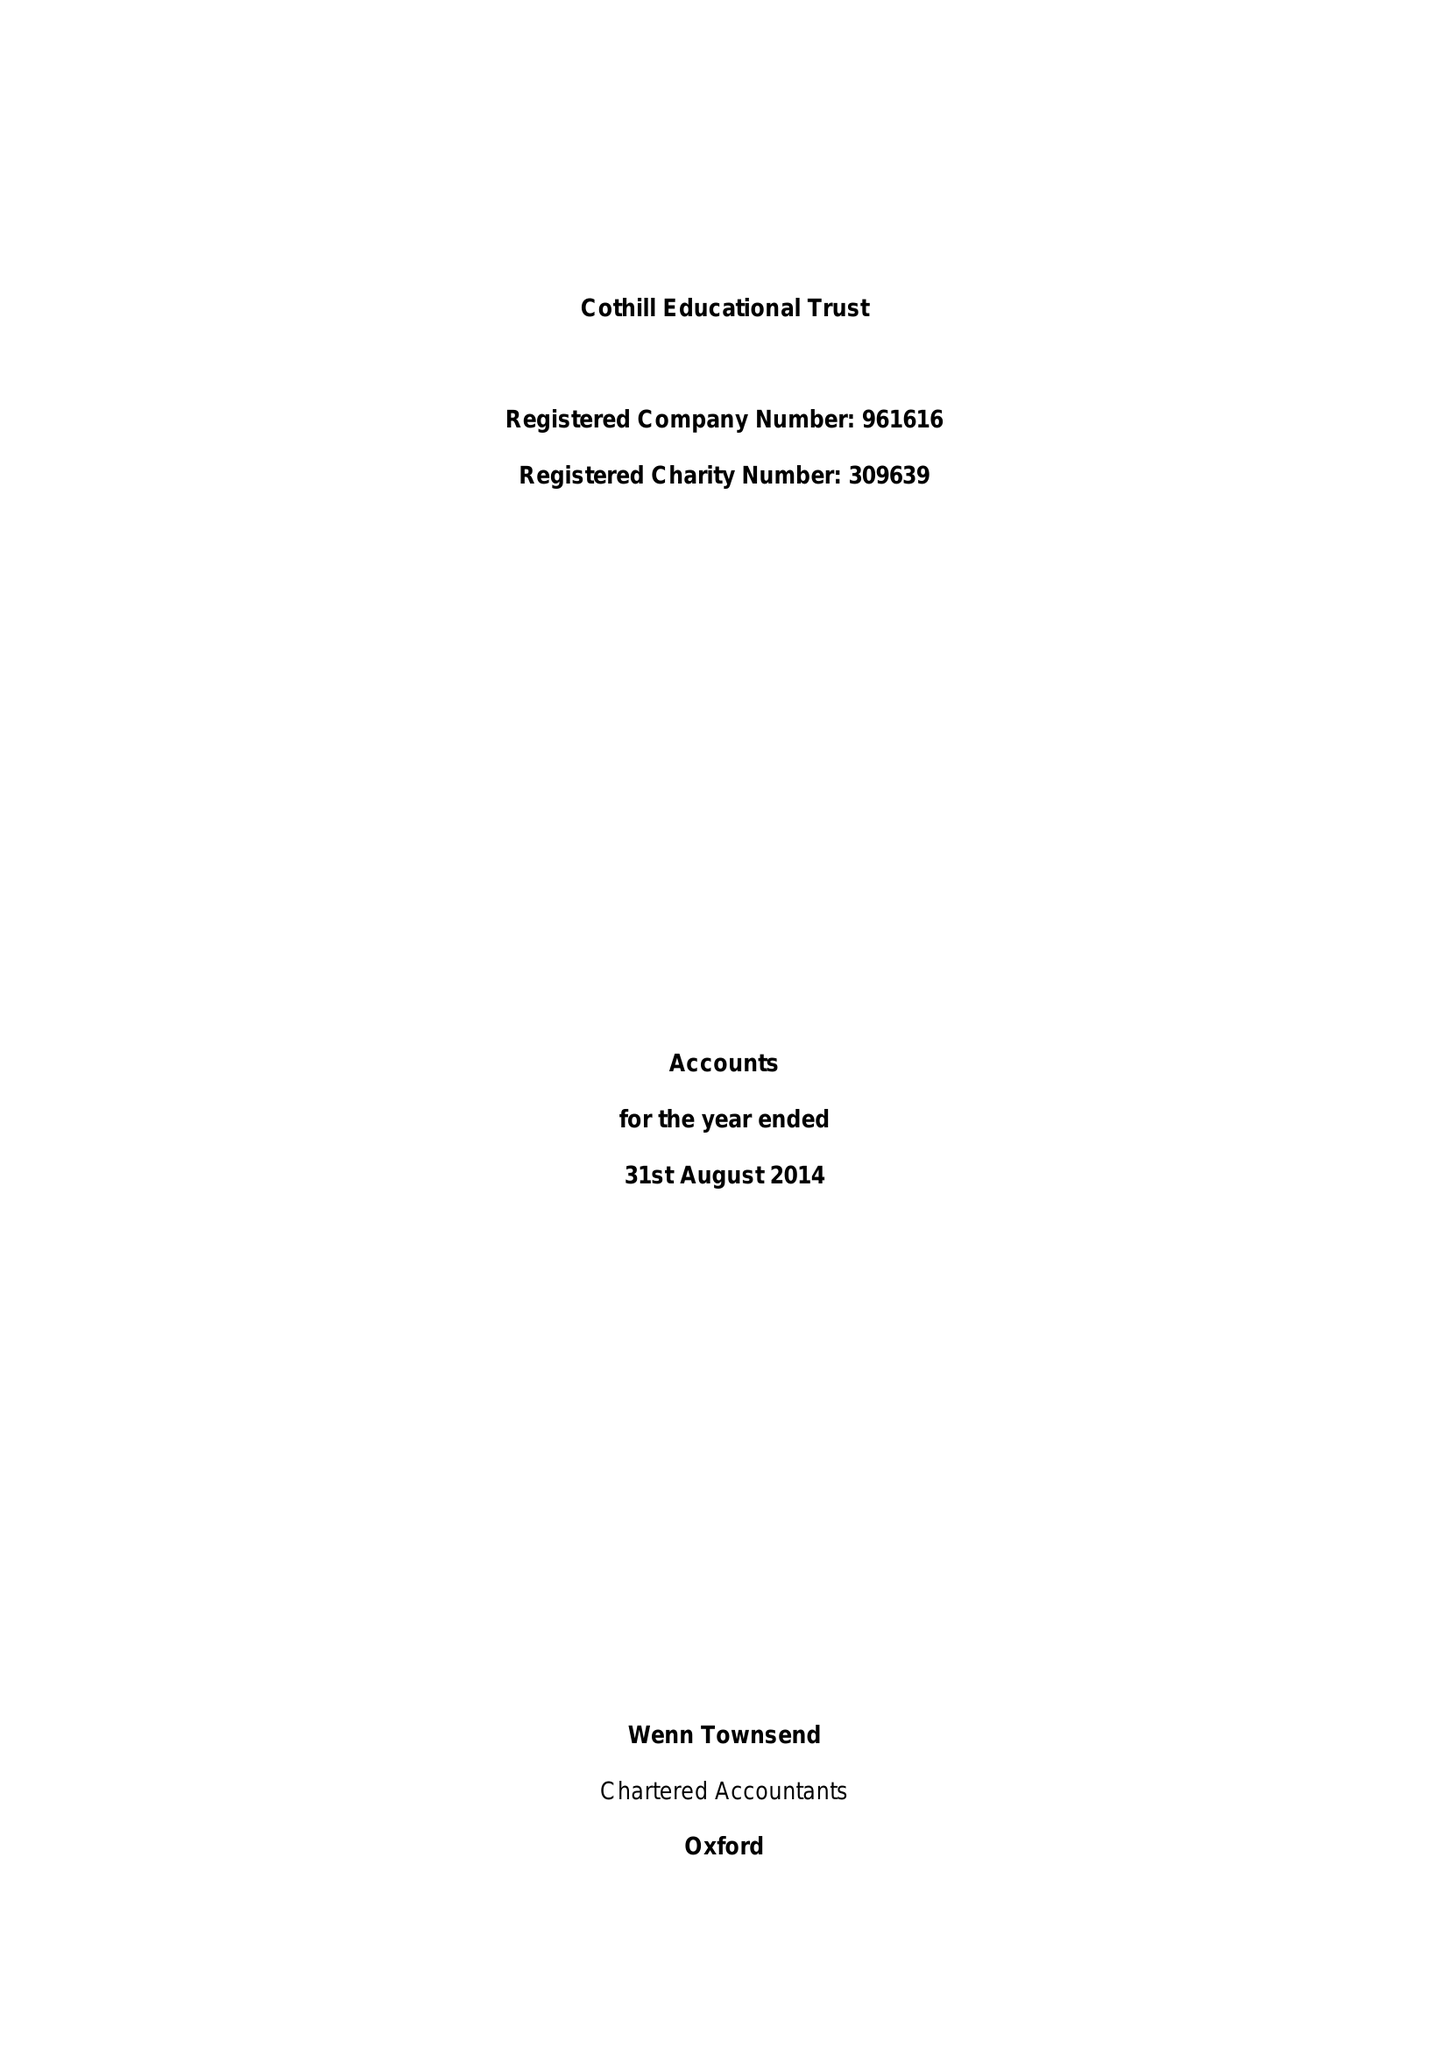What is the value for the income_annually_in_british_pounds?
Answer the question using a single word or phrase. 17658935.00 